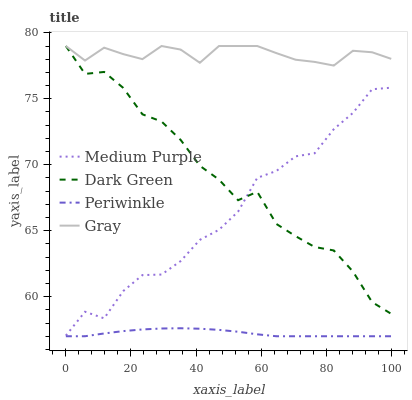Does Periwinkle have the minimum area under the curve?
Answer yes or no. Yes. Does Gray have the maximum area under the curve?
Answer yes or no. Yes. Does Gray have the minimum area under the curve?
Answer yes or no. No. Does Periwinkle have the maximum area under the curve?
Answer yes or no. No. Is Periwinkle the smoothest?
Answer yes or no. Yes. Is Dark Green the roughest?
Answer yes or no. Yes. Is Gray the smoothest?
Answer yes or no. No. Is Gray the roughest?
Answer yes or no. No. Does Periwinkle have the lowest value?
Answer yes or no. Yes. Does Gray have the lowest value?
Answer yes or no. No. Does Dark Green have the highest value?
Answer yes or no. Yes. Does Periwinkle have the highest value?
Answer yes or no. No. Is Periwinkle less than Medium Purple?
Answer yes or no. Yes. Is Medium Purple greater than Periwinkle?
Answer yes or no. Yes. Does Medium Purple intersect Dark Green?
Answer yes or no. Yes. Is Medium Purple less than Dark Green?
Answer yes or no. No. Is Medium Purple greater than Dark Green?
Answer yes or no. No. Does Periwinkle intersect Medium Purple?
Answer yes or no. No. 